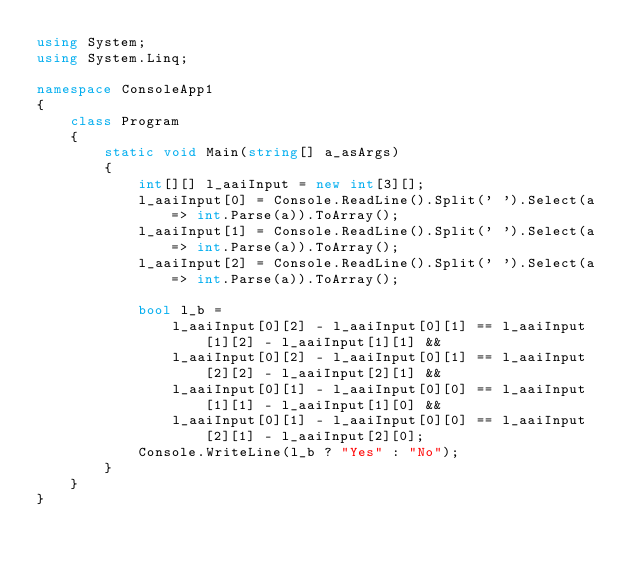<code> <loc_0><loc_0><loc_500><loc_500><_C#_>using System;
using System.Linq;

namespace ConsoleApp1
{
    class Program
    {
        static void Main(string[] a_asArgs)
        {
			int[][] l_aaiInput = new int[3][];
			l_aaiInput[0] = Console.ReadLine().Split(' ').Select(a => int.Parse(a)).ToArray();
			l_aaiInput[1] = Console.ReadLine().Split(' ').Select(a => int.Parse(a)).ToArray();
			l_aaiInput[2] = Console.ReadLine().Split(' ').Select(a => int.Parse(a)).ToArray();

			bool l_b =
				l_aaiInput[0][2] - l_aaiInput[0][1] == l_aaiInput[1][2] - l_aaiInput[1][1] &&
				l_aaiInput[0][2] - l_aaiInput[0][1] == l_aaiInput[2][2] - l_aaiInput[2][1] &&
				l_aaiInput[0][1] - l_aaiInput[0][0] == l_aaiInput[1][1] - l_aaiInput[1][0] &&
				l_aaiInput[0][1] - l_aaiInput[0][0] == l_aaiInput[2][1] - l_aaiInput[2][0];
			Console.WriteLine(l_b ? "Yes" : "No");
		}
	}
}
</code> 